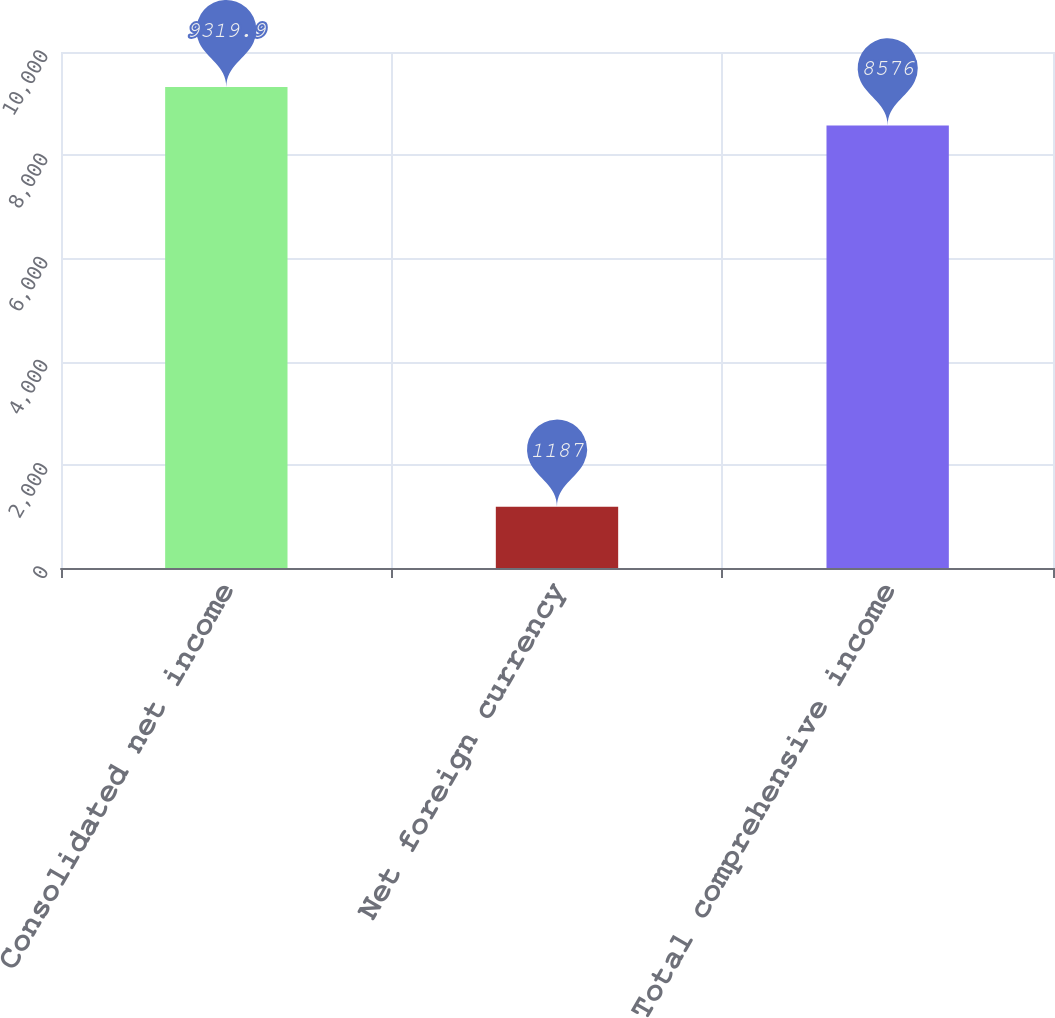Convert chart to OTSL. <chart><loc_0><loc_0><loc_500><loc_500><bar_chart><fcel>Consolidated net income<fcel>Net foreign currency<fcel>Total comprehensive income<nl><fcel>9319.9<fcel>1187<fcel>8576<nl></chart> 